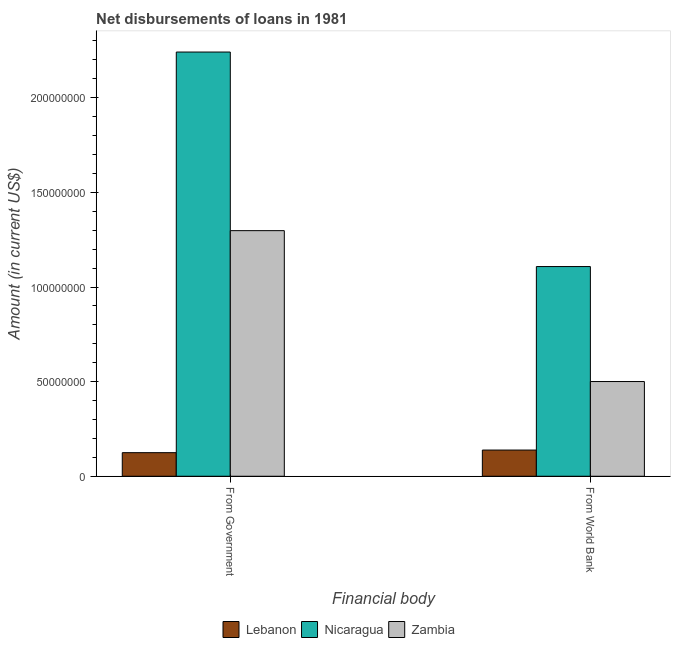How many different coloured bars are there?
Keep it short and to the point. 3. Are the number of bars on each tick of the X-axis equal?
Your answer should be compact. Yes. How many bars are there on the 1st tick from the right?
Keep it short and to the point. 3. What is the label of the 2nd group of bars from the left?
Give a very brief answer. From World Bank. What is the net disbursements of loan from world bank in Lebanon?
Give a very brief answer. 1.38e+07. Across all countries, what is the maximum net disbursements of loan from government?
Make the answer very short. 2.24e+08. Across all countries, what is the minimum net disbursements of loan from world bank?
Your answer should be compact. 1.38e+07. In which country was the net disbursements of loan from world bank maximum?
Your response must be concise. Nicaragua. In which country was the net disbursements of loan from world bank minimum?
Keep it short and to the point. Lebanon. What is the total net disbursements of loan from world bank in the graph?
Make the answer very short. 1.75e+08. What is the difference between the net disbursements of loan from world bank in Lebanon and that in Nicaragua?
Provide a succinct answer. -9.70e+07. What is the difference between the net disbursements of loan from government in Lebanon and the net disbursements of loan from world bank in Zambia?
Keep it short and to the point. -3.76e+07. What is the average net disbursements of loan from government per country?
Provide a short and direct response. 1.22e+08. What is the difference between the net disbursements of loan from government and net disbursements of loan from world bank in Lebanon?
Offer a very short reply. -1.38e+06. What is the ratio of the net disbursements of loan from government in Nicaragua to that in Zambia?
Your response must be concise. 1.73. In how many countries, is the net disbursements of loan from world bank greater than the average net disbursements of loan from world bank taken over all countries?
Your answer should be very brief. 1. What does the 3rd bar from the left in From World Bank represents?
Give a very brief answer. Zambia. What does the 1st bar from the right in From World Bank represents?
Offer a very short reply. Zambia. How many bars are there?
Offer a terse response. 6. Are all the bars in the graph horizontal?
Offer a terse response. No. How many countries are there in the graph?
Offer a terse response. 3. What is the difference between two consecutive major ticks on the Y-axis?
Provide a short and direct response. 5.00e+07. Are the values on the major ticks of Y-axis written in scientific E-notation?
Make the answer very short. No. Does the graph contain any zero values?
Provide a succinct answer. No. Where does the legend appear in the graph?
Keep it short and to the point. Bottom center. How many legend labels are there?
Your answer should be very brief. 3. What is the title of the graph?
Your response must be concise. Net disbursements of loans in 1981. Does "Croatia" appear as one of the legend labels in the graph?
Keep it short and to the point. No. What is the label or title of the X-axis?
Make the answer very short. Financial body. What is the label or title of the Y-axis?
Make the answer very short. Amount (in current US$). What is the Amount (in current US$) in Lebanon in From Government?
Ensure brevity in your answer.  1.25e+07. What is the Amount (in current US$) of Nicaragua in From Government?
Give a very brief answer. 2.24e+08. What is the Amount (in current US$) in Zambia in From Government?
Offer a very short reply. 1.30e+08. What is the Amount (in current US$) of Lebanon in From World Bank?
Provide a succinct answer. 1.38e+07. What is the Amount (in current US$) in Nicaragua in From World Bank?
Make the answer very short. 1.11e+08. What is the Amount (in current US$) in Zambia in From World Bank?
Provide a succinct answer. 5.00e+07. Across all Financial body, what is the maximum Amount (in current US$) of Lebanon?
Keep it short and to the point. 1.38e+07. Across all Financial body, what is the maximum Amount (in current US$) of Nicaragua?
Give a very brief answer. 2.24e+08. Across all Financial body, what is the maximum Amount (in current US$) of Zambia?
Your answer should be very brief. 1.30e+08. Across all Financial body, what is the minimum Amount (in current US$) in Lebanon?
Provide a succinct answer. 1.25e+07. Across all Financial body, what is the minimum Amount (in current US$) of Nicaragua?
Your answer should be compact. 1.11e+08. Across all Financial body, what is the minimum Amount (in current US$) of Zambia?
Ensure brevity in your answer.  5.00e+07. What is the total Amount (in current US$) in Lebanon in the graph?
Your answer should be compact. 2.63e+07. What is the total Amount (in current US$) of Nicaragua in the graph?
Give a very brief answer. 3.35e+08. What is the total Amount (in current US$) of Zambia in the graph?
Make the answer very short. 1.80e+08. What is the difference between the Amount (in current US$) in Lebanon in From Government and that in From World Bank?
Your answer should be compact. -1.38e+06. What is the difference between the Amount (in current US$) of Nicaragua in From Government and that in From World Bank?
Offer a very short reply. 1.13e+08. What is the difference between the Amount (in current US$) in Zambia in From Government and that in From World Bank?
Give a very brief answer. 7.97e+07. What is the difference between the Amount (in current US$) of Lebanon in From Government and the Amount (in current US$) of Nicaragua in From World Bank?
Provide a short and direct response. -9.83e+07. What is the difference between the Amount (in current US$) in Lebanon in From Government and the Amount (in current US$) in Zambia in From World Bank?
Ensure brevity in your answer.  -3.76e+07. What is the difference between the Amount (in current US$) of Nicaragua in From Government and the Amount (in current US$) of Zambia in From World Bank?
Keep it short and to the point. 1.74e+08. What is the average Amount (in current US$) of Lebanon per Financial body?
Your response must be concise. 1.32e+07. What is the average Amount (in current US$) of Nicaragua per Financial body?
Provide a succinct answer. 1.67e+08. What is the average Amount (in current US$) in Zambia per Financial body?
Your answer should be very brief. 8.99e+07. What is the difference between the Amount (in current US$) of Lebanon and Amount (in current US$) of Nicaragua in From Government?
Your answer should be compact. -2.12e+08. What is the difference between the Amount (in current US$) of Lebanon and Amount (in current US$) of Zambia in From Government?
Give a very brief answer. -1.17e+08. What is the difference between the Amount (in current US$) in Nicaragua and Amount (in current US$) in Zambia in From Government?
Your answer should be very brief. 9.44e+07. What is the difference between the Amount (in current US$) of Lebanon and Amount (in current US$) of Nicaragua in From World Bank?
Give a very brief answer. -9.70e+07. What is the difference between the Amount (in current US$) in Lebanon and Amount (in current US$) in Zambia in From World Bank?
Make the answer very short. -3.62e+07. What is the difference between the Amount (in current US$) of Nicaragua and Amount (in current US$) of Zambia in From World Bank?
Give a very brief answer. 6.08e+07. What is the ratio of the Amount (in current US$) in Lebanon in From Government to that in From World Bank?
Offer a very short reply. 0.9. What is the ratio of the Amount (in current US$) in Nicaragua in From Government to that in From World Bank?
Offer a very short reply. 2.02. What is the ratio of the Amount (in current US$) of Zambia in From Government to that in From World Bank?
Your answer should be very brief. 2.59. What is the difference between the highest and the second highest Amount (in current US$) of Lebanon?
Offer a very short reply. 1.38e+06. What is the difference between the highest and the second highest Amount (in current US$) in Nicaragua?
Keep it short and to the point. 1.13e+08. What is the difference between the highest and the second highest Amount (in current US$) of Zambia?
Your response must be concise. 7.97e+07. What is the difference between the highest and the lowest Amount (in current US$) of Lebanon?
Offer a terse response. 1.38e+06. What is the difference between the highest and the lowest Amount (in current US$) of Nicaragua?
Your answer should be compact. 1.13e+08. What is the difference between the highest and the lowest Amount (in current US$) in Zambia?
Give a very brief answer. 7.97e+07. 